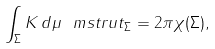<formula> <loc_0><loc_0><loc_500><loc_500>\int _ { \Sigma } K \, d \mu \ m s t r u t _ { \Sigma } = 2 \pi \chi ( \Sigma ) ,</formula> 